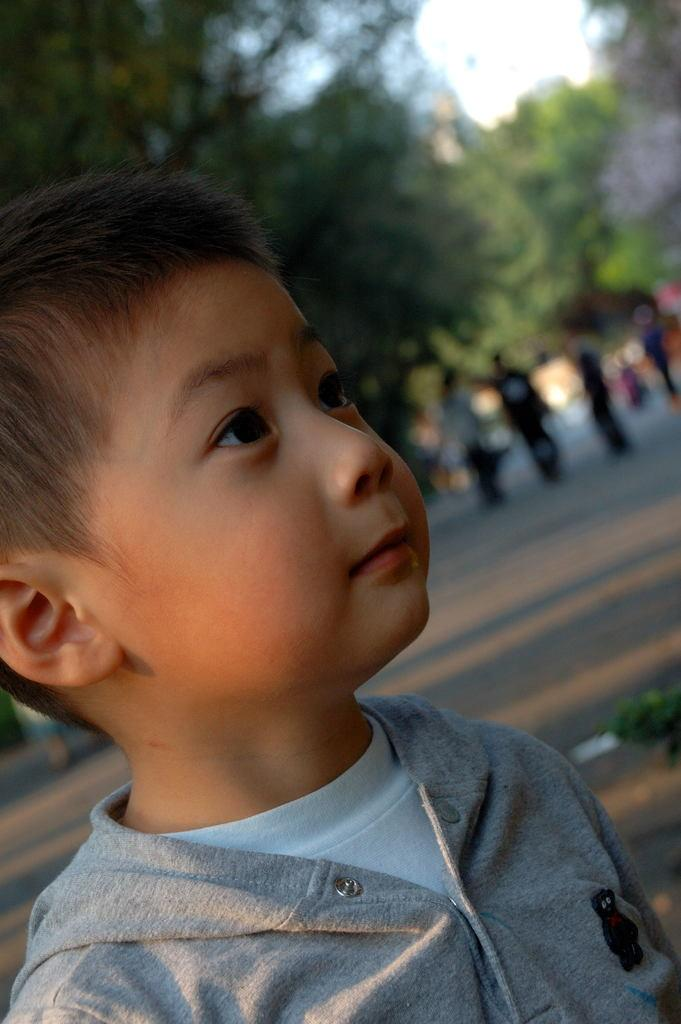Who is the main subject in the image? There is a boy in the image. What is the boy wearing? The boy is wearing a gray t-shirt. What is the boy doing in the image? The boy is watching something. What can be seen in the background of the image? There are persons on the road and trees in the background of the image. What part of the natural environment is visible in the image? The sky is visible in the background of the image. Does the boy's sister need to give her approval for him to watch the event in the image? There is no mention of a sister in the image, so it is not possible to determine if her approval is needed. 